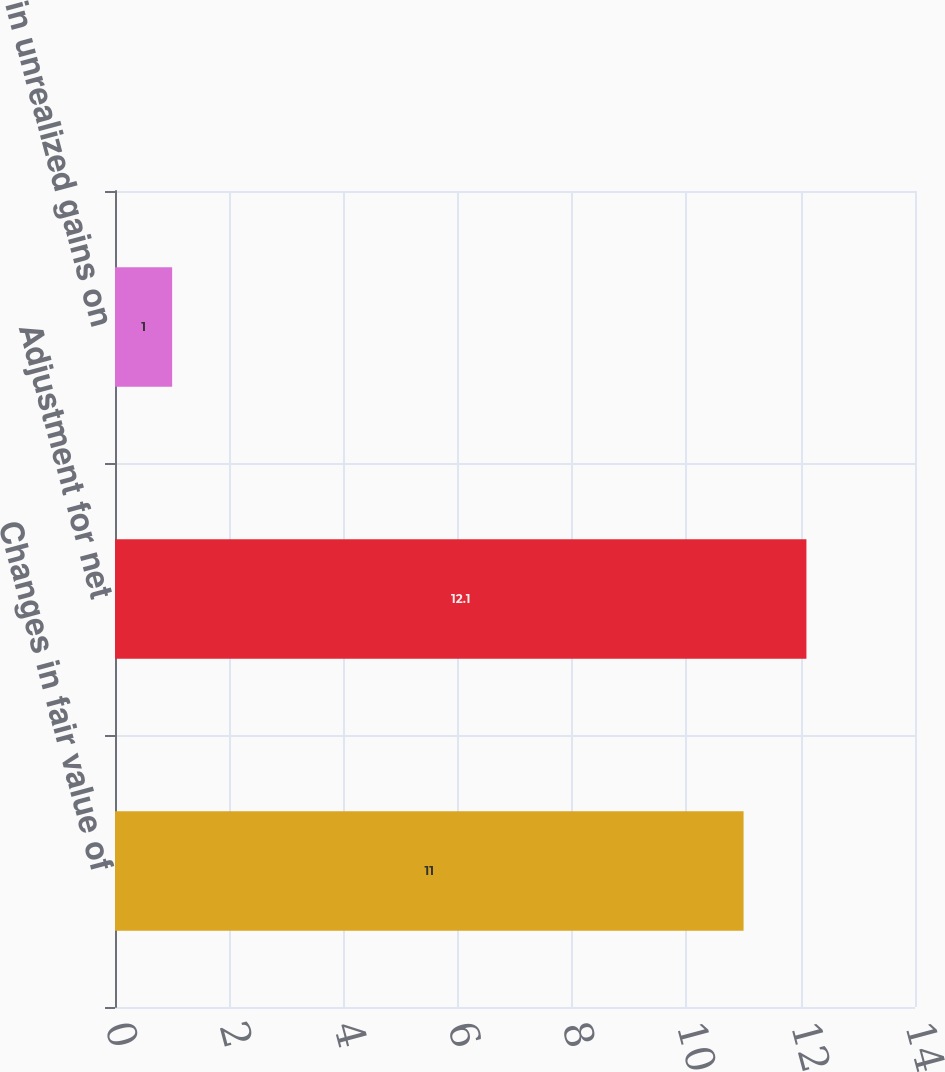<chart> <loc_0><loc_0><loc_500><loc_500><bar_chart><fcel>Changes in fair value of<fcel>Adjustment for net<fcel>Change in unrealized gains on<nl><fcel>11<fcel>12.1<fcel>1<nl></chart> 